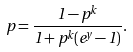<formula> <loc_0><loc_0><loc_500><loc_500>p = \frac { 1 - p ^ { k } } { 1 + p ^ { k } ( e ^ { y } - 1 ) } .</formula> 